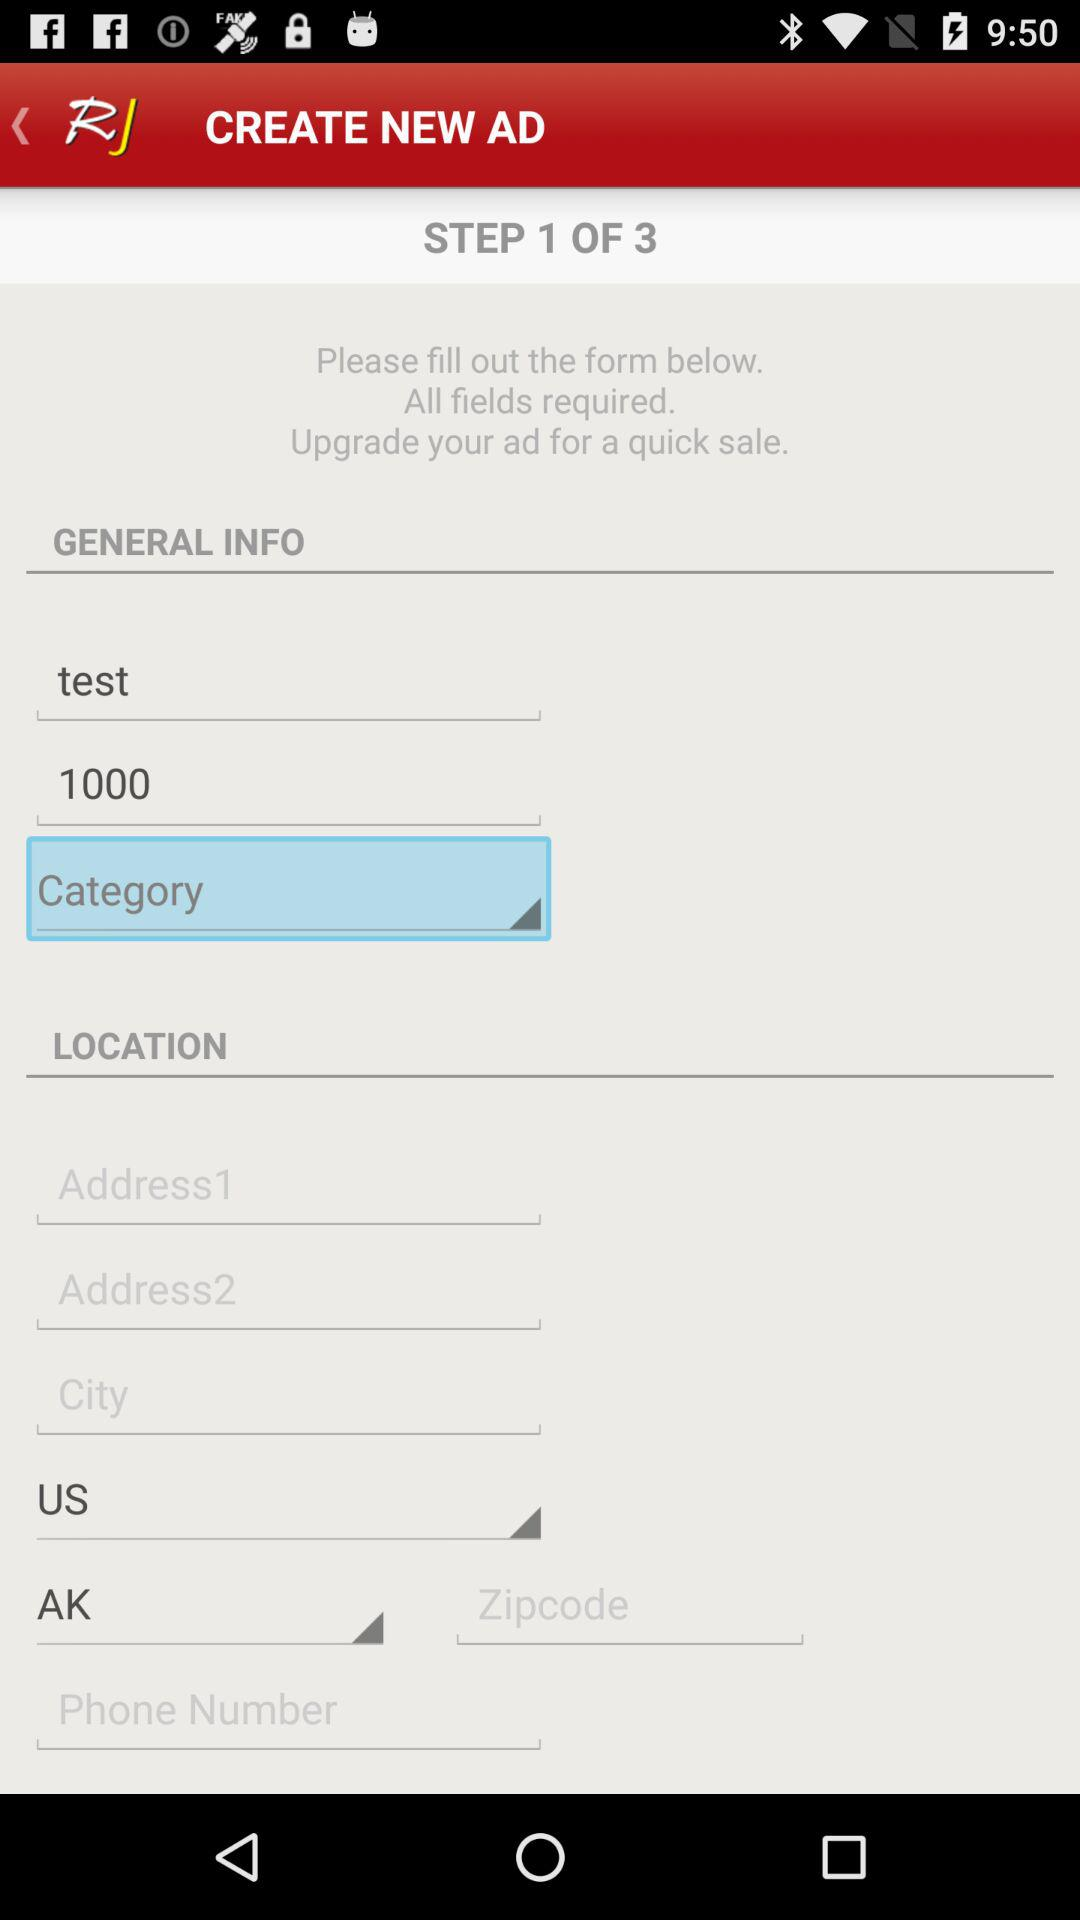How many steps are there? There are 3 steps. 